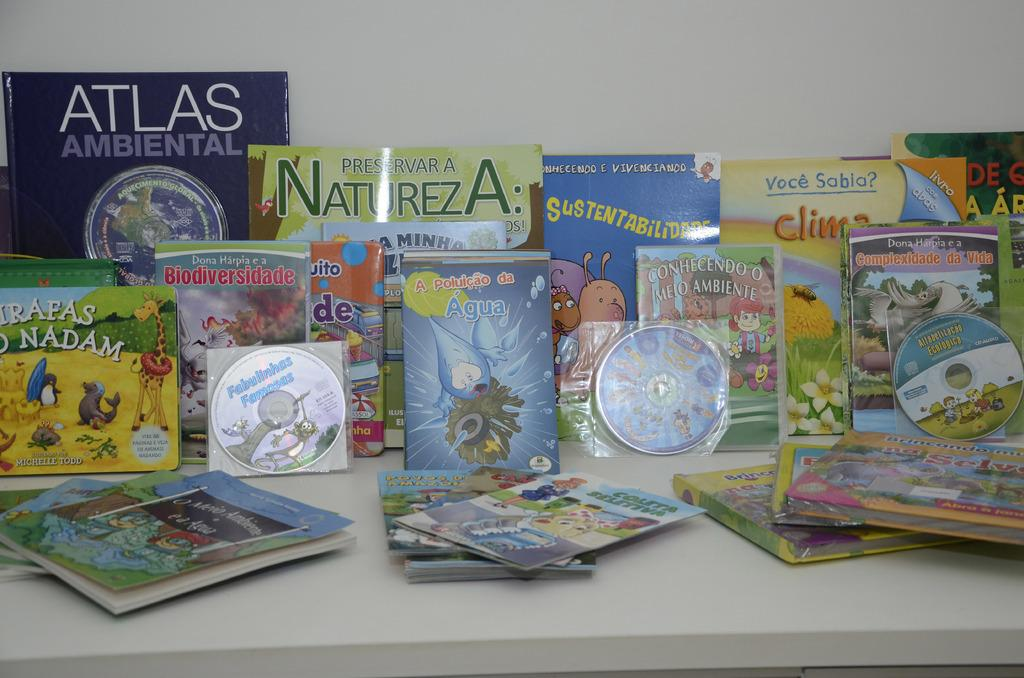<image>
Offer a succinct explanation of the picture presented. A book with the title Agua is surrounded by others. 